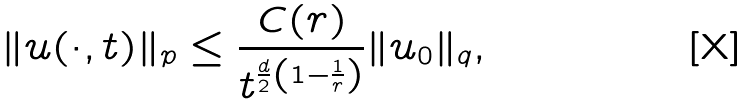Convert formula to latex. <formula><loc_0><loc_0><loc_500><loc_500>\| u ( \cdot , t ) \| _ { p } \leq \frac { C ( r ) } { t ^ { \frac { d } { 2 } \left ( 1 - \frac { 1 } { r } \right ) } } \| u _ { 0 } \| _ { q } ,</formula> 